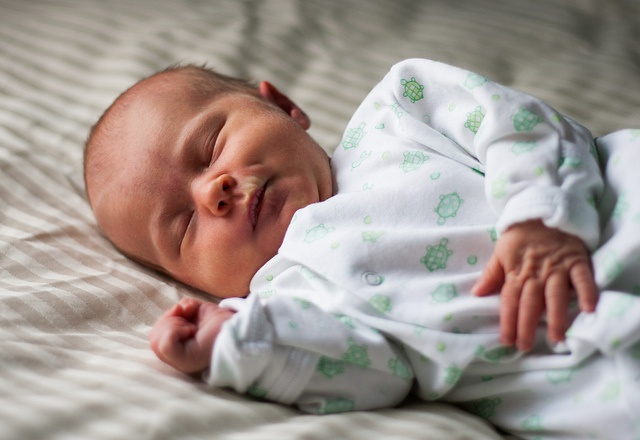Describe the objects in this image and their specific colors. I can see people in gray, lightgray, darkgray, and brown tones and bed in gray, darkgray, and lightgray tones in this image. 